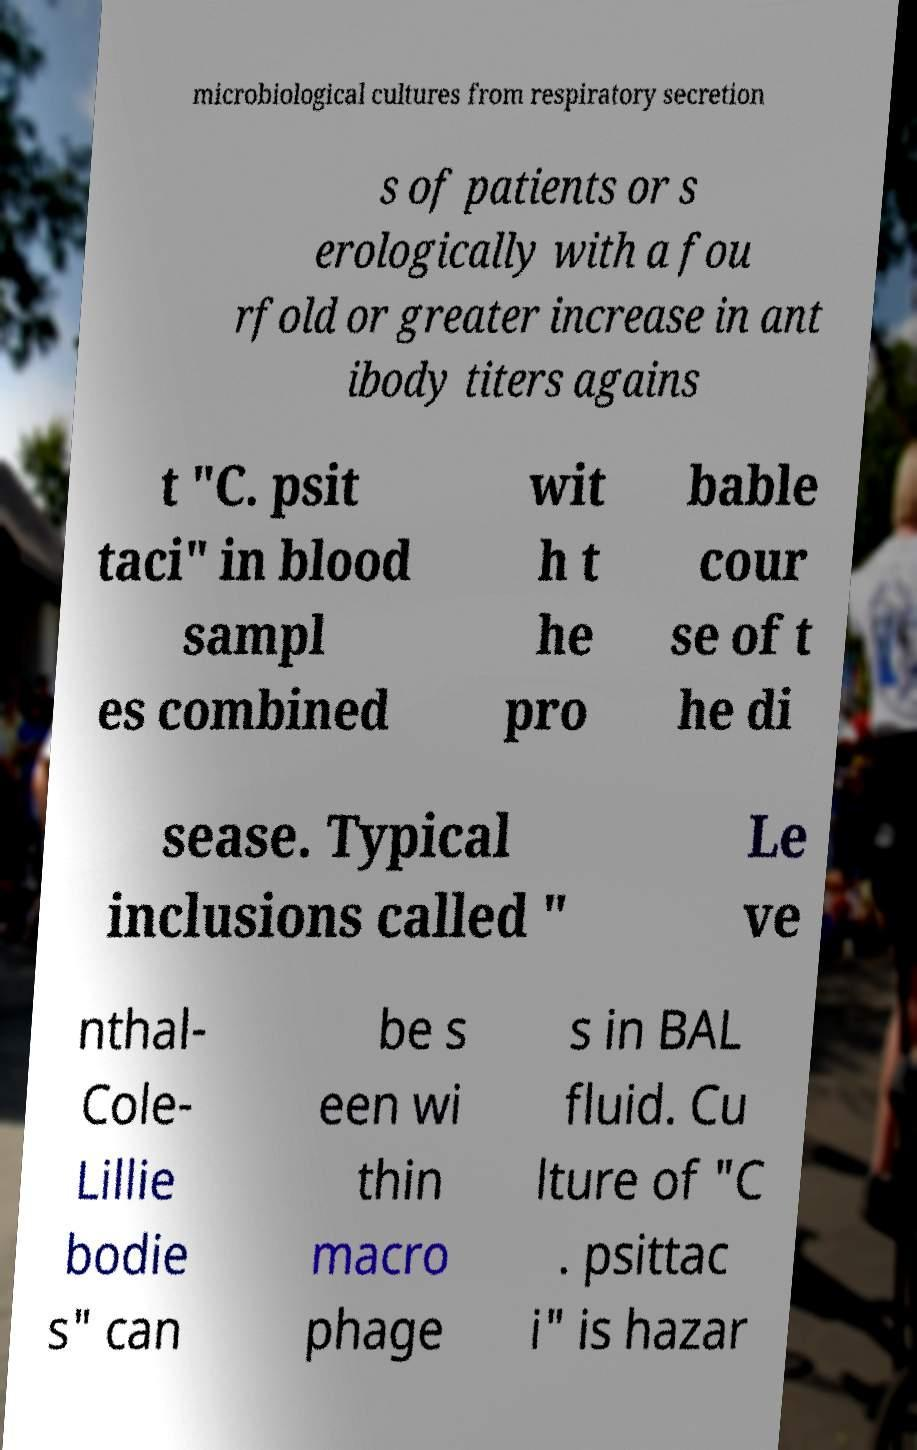Could you assist in decoding the text presented in this image and type it out clearly? microbiological cultures from respiratory secretion s of patients or s erologically with a fou rfold or greater increase in ant ibody titers agains t "C. psit taci" in blood sampl es combined wit h t he pro bable cour se of t he di sease. Typical inclusions called " Le ve nthal- Cole- Lillie bodie s" can be s een wi thin macro phage s in BAL fluid. Cu lture of "C . psittac i" is hazar 